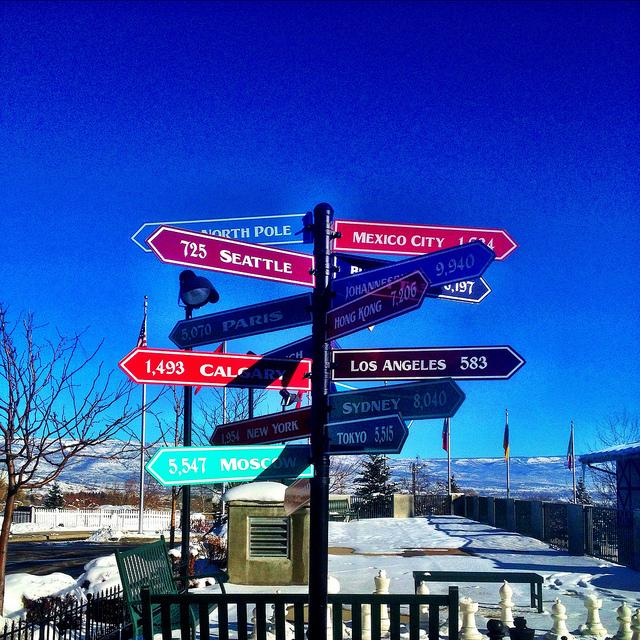What kind of locations are mentioned in the signs? cities 